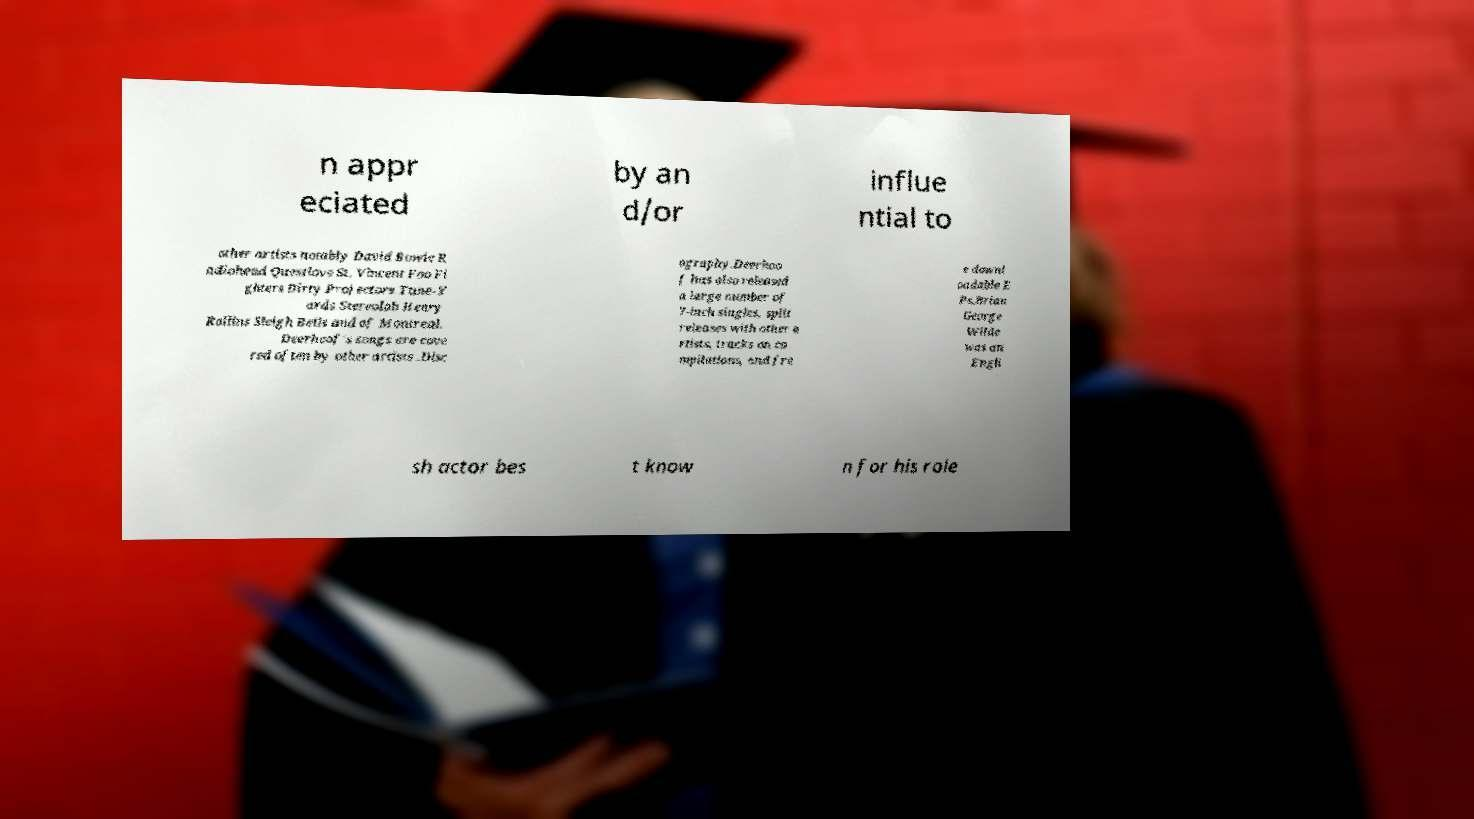What messages or text are displayed in this image? I need them in a readable, typed format. n appr eciated by an d/or influe ntial to other artists notably David Bowie R adiohead Questlove St. Vincent Foo Fi ghters Dirty Projectors Tune-Y ards Stereolab Henry Rollins Sleigh Bells and of Montreal. Deerhoof's songs are cove red often by other artists .Disc ography.Deerhoo f has also released a large number of 7-inch singles, split releases with other a rtists, tracks on co mpilations, and fre e downl oadable E Ps.Brian George Wilde was an Engli sh actor bes t know n for his role 